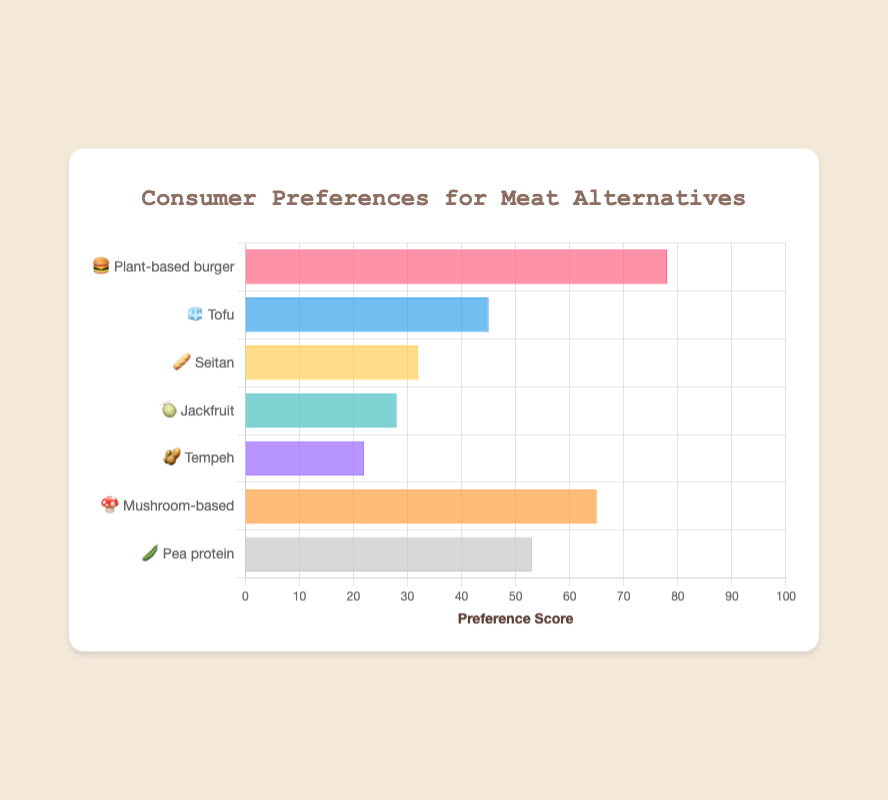What's the most preferred meat alternative according to the chart? The chart indicates consumer preferences for various meat alternatives. The bar corresponding to 🍔 Plant-based burger reaches the highest preference score of 78, making it the most preferred.
Answer: Plant-based burger 🍔 What's the preference score for 🫛 Pea protein? By locating the bar labeled 🫛 Pea protein on the chart, it reaches a value of 53 on the preference score axis.
Answer: 53 What's the combined preference score of 🧊 Tofu and 🍈 Jackfruit? The preference score for 🧊 Tofu is 45, and for 🍈 Jackfruit, it is 28. Adding these two scores together results in 45 + 28 = 73.
Answer: 73 Which meat alternative has a higher preference score, 🍄 Mushroom-based or 🥜 Tempeh? Observing the preference scores for 🍄 Mushroom-based (65) and 🥜 Tempeh (22), it is clear that 🍄 Mushroom-based has a higher score.
Answer: Mushroom-based 🍄 What is the preference score difference between 🥖 Seitan and 🍄 Mushroom-based? The preference score for 🥖 Seitan is 32 and for 🍄 Mushroom-based is 65. The difference is 65 - 32 = 33.
Answer: 33 Arrange the meat alternatives in descending order of preference scores. The preference scores are: 
🍔 Plant-based burger (78), 🍄 Mushroom-based (65), 🫛 Pea protein (53), 🧊 Tofu (45), 🥖 Seitan (32), 🍈 Jackfruit (28), 🥜 Tempeh (22). So, the order from highest to lowest is: 🍔 Plant-based burger, 🍄 Mushroom-based, 🫛 Pea protein, 🧊 Tofu, 🥖 Seitan, 🍈 Jackfruit, 🥜 Tempeh.
Answer: 🍔 Plant-based burger, 🍄 Mushroom-based, 🫛 Pea protein, 🧊 Tofu, 🥖 Seitan, 🍈 Jackfruit, 🥜 Tempeh What is the average preference score for all meat alternatives? Adding all the preference scores: 78 + 45 + 32 + 28 + 22 + 65 + 53 = 323. There are 7 meat alternatives, so the average is 323 / 7 ≈ 46.14.
Answer: 46.14 What percentage of the highest preference score does 🥖 Seitan have? The highest preference score is 78. The score for 🥖 Seitan is 32. The percentage is (32 / 78) * 100 ≈ 41.03%.
Answer: 41.03% 